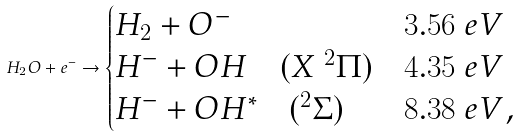<formula> <loc_0><loc_0><loc_500><loc_500>H _ { 2 } O + e ^ { - } \to \begin{cases} H _ { 2 } + O ^ { - } & 3 . 5 6 \ e V \\ H ^ { - } + O H \quad ( X \ ^ { 2 } \Pi ) & 4 . 3 5 \ e V \\ H ^ { - } + O H ^ { * } \quad ( ^ { 2 } \Sigma ) & 8 . 3 8 \ e V , \end{cases}</formula> 